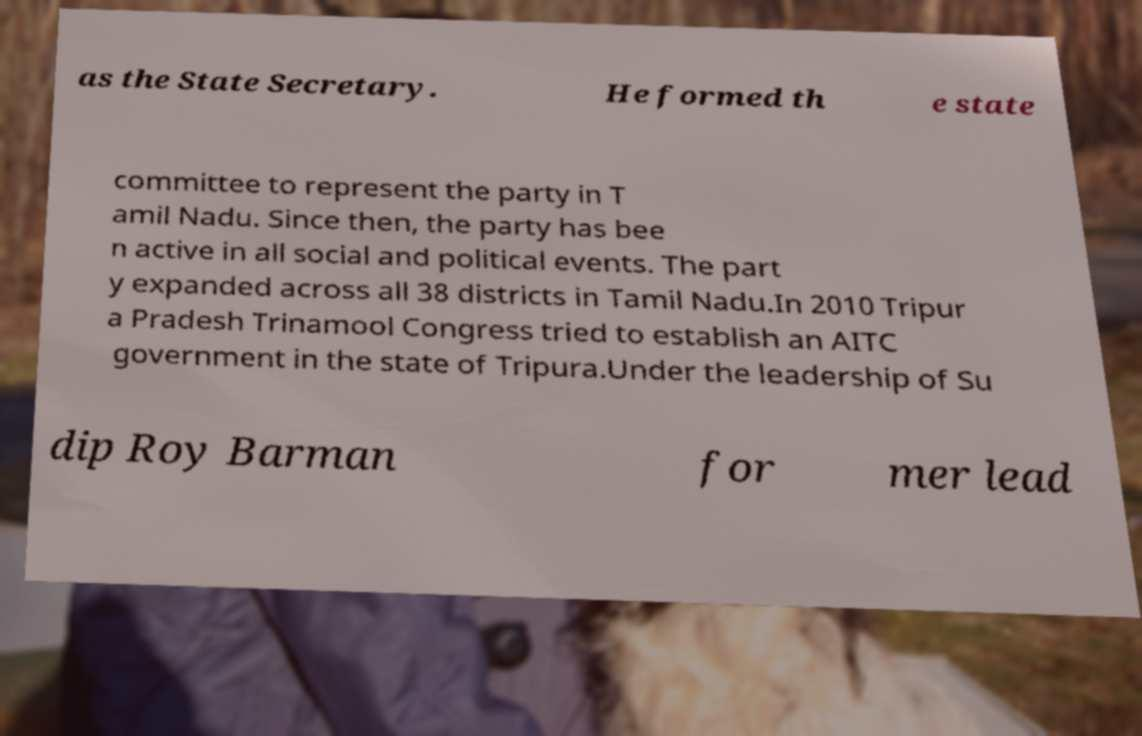Please read and relay the text visible in this image. What does it say? as the State Secretary. He formed th e state committee to represent the party in T amil Nadu. Since then, the party has bee n active in all social and political events. The part y expanded across all 38 districts in Tamil Nadu.In 2010 Tripur a Pradesh Trinamool Congress tried to establish an AITC government in the state of Tripura.Under the leadership of Su dip Roy Barman for mer lead 